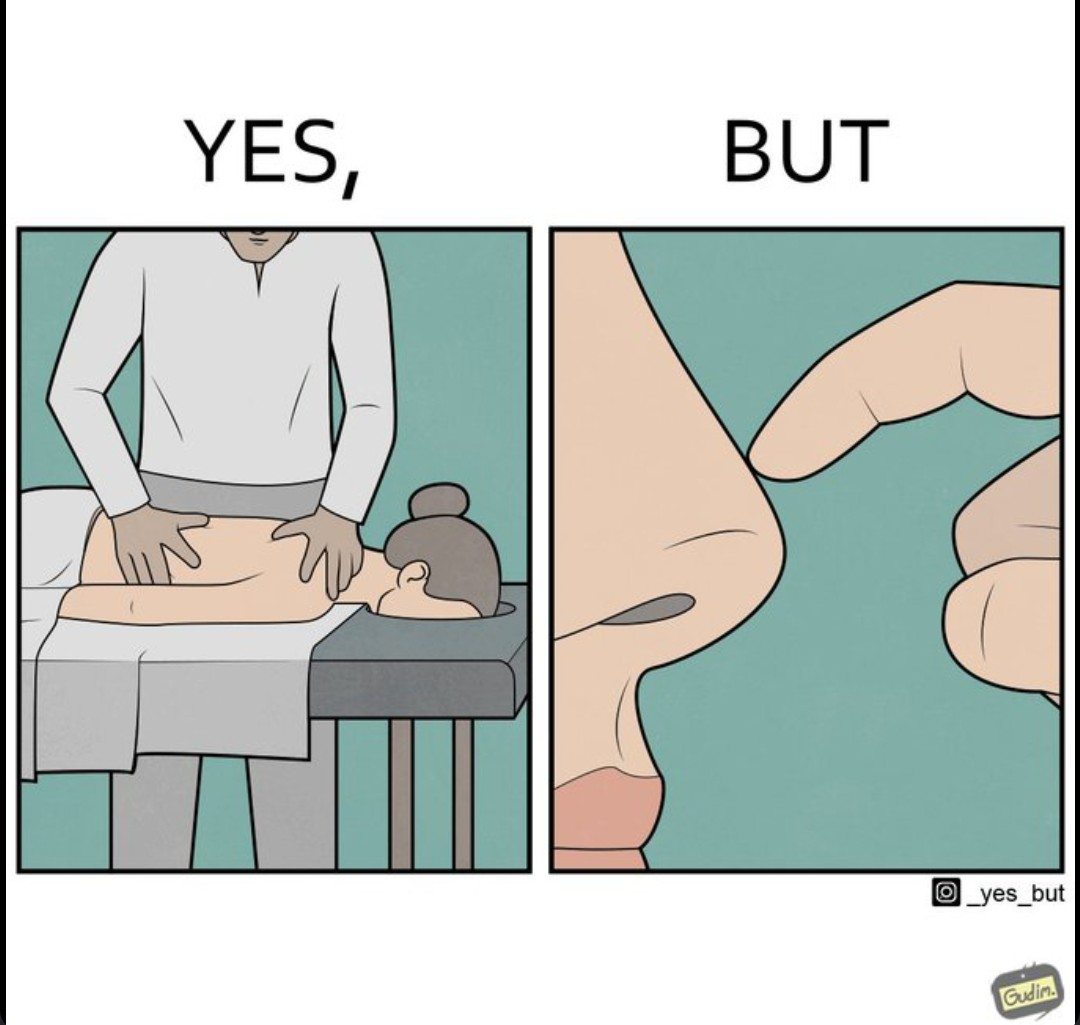Compare the left and right sides of this image. In the left part of the image: It is a woman getting a full body massage from a masseuse. In the right part of the image: It is a woman scratching her nose 